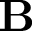Convert formula to latex. <formula><loc_0><loc_0><loc_500><loc_500>B</formula> 